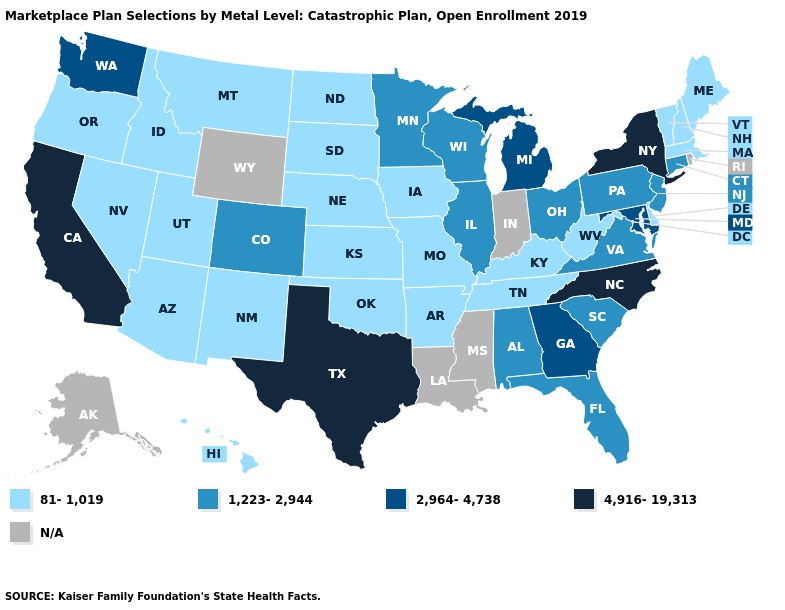What is the lowest value in the USA?
Be succinct. 81-1,019. Name the states that have a value in the range 2,964-4,738?
Answer briefly. Georgia, Maryland, Michigan, Washington. Name the states that have a value in the range 81-1,019?
Give a very brief answer. Arizona, Arkansas, Delaware, Hawaii, Idaho, Iowa, Kansas, Kentucky, Maine, Massachusetts, Missouri, Montana, Nebraska, Nevada, New Hampshire, New Mexico, North Dakota, Oklahoma, Oregon, South Dakota, Tennessee, Utah, Vermont, West Virginia. Which states have the highest value in the USA?
Give a very brief answer. California, New York, North Carolina, Texas. Does Maryland have the lowest value in the USA?
Concise answer only. No. Name the states that have a value in the range N/A?
Write a very short answer. Alaska, Indiana, Louisiana, Mississippi, Rhode Island, Wyoming. What is the highest value in the West ?
Keep it brief. 4,916-19,313. What is the value of Kansas?
Concise answer only. 81-1,019. What is the highest value in the USA?
Quick response, please. 4,916-19,313. What is the highest value in states that border Washington?
Concise answer only. 81-1,019. Name the states that have a value in the range 4,916-19,313?
Concise answer only. California, New York, North Carolina, Texas. Which states have the lowest value in the South?
Give a very brief answer. Arkansas, Delaware, Kentucky, Oklahoma, Tennessee, West Virginia. Does Wisconsin have the lowest value in the USA?
Short answer required. No. 